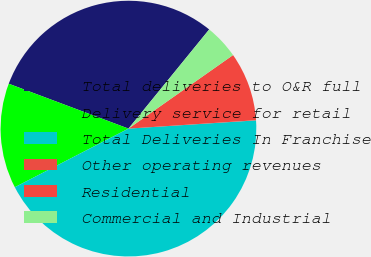Convert chart to OTSL. <chart><loc_0><loc_0><loc_500><loc_500><pie_chart><fcel>Total deliveries to O&R full<fcel>Delivery service for retail<fcel>Total Deliveries In Franchise<fcel>Other operating revenues<fcel>Residential<fcel>Commercial and Industrial<nl><fcel>30.17%<fcel>13.29%<fcel>43.45%<fcel>0.02%<fcel>8.71%<fcel>4.37%<nl></chart> 